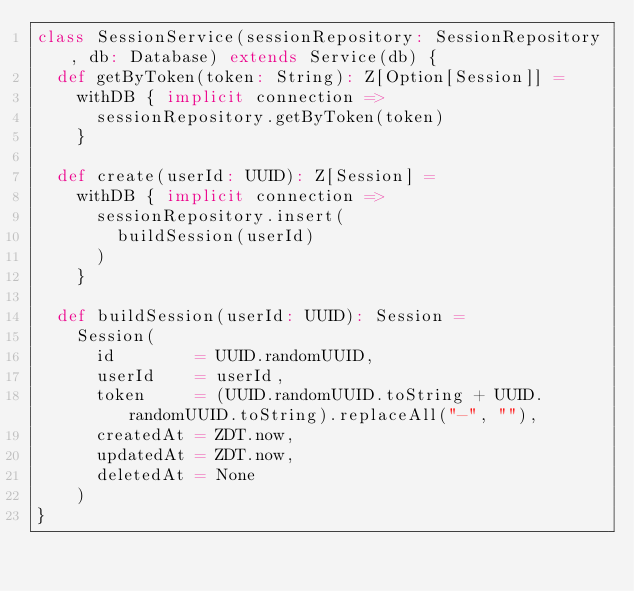Convert code to text. <code><loc_0><loc_0><loc_500><loc_500><_Scala_>class SessionService(sessionRepository: SessionRepository, db: Database) extends Service(db) {
  def getByToken(token: String): Z[Option[Session]] =
    withDB { implicit connection =>
      sessionRepository.getByToken(token)
    }

  def create(userId: UUID): Z[Session] =
    withDB { implicit connection =>
      sessionRepository.insert(
        buildSession(userId)
      )
    }

  def buildSession(userId: UUID): Session =
    Session(
      id        = UUID.randomUUID,
      userId    = userId,
      token     = (UUID.randomUUID.toString + UUID.randomUUID.toString).replaceAll("-", ""),
      createdAt = ZDT.now,
      updatedAt = ZDT.now,
      deletedAt = None
    )
}
</code> 